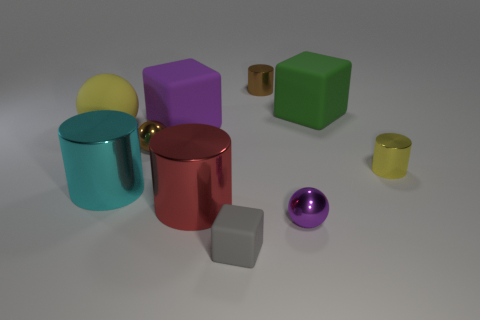There is a matte thing that is on the right side of the tiny metal ball that is in front of the small yellow shiny cylinder; what size is it?
Provide a short and direct response. Large. There is a yellow object on the left side of the tiny metal cylinder right of the small ball right of the tiny gray object; what is its shape?
Offer a terse response. Sphere. What color is the tiny object that is made of the same material as the large purple object?
Your answer should be compact. Gray. There is a large matte cube that is to the right of the large cylinder on the right side of the metallic ball on the left side of the red cylinder; what color is it?
Ensure brevity in your answer.  Green. How many balls are either yellow objects or brown things?
Offer a terse response. 2. There is a cylinder that is the same color as the rubber ball; what is its material?
Give a very brief answer. Metal. Do the tiny rubber object and the thing that is behind the big green block have the same color?
Offer a very short reply. No. What is the color of the tiny cube?
Offer a very short reply. Gray. What number of things are either big red metal cylinders or small rubber blocks?
Your answer should be very brief. 2. What is the material of the red thing that is the same size as the cyan cylinder?
Ensure brevity in your answer.  Metal. 